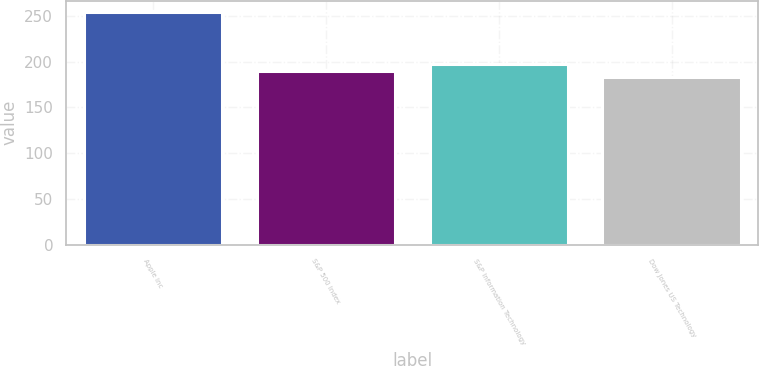<chart> <loc_0><loc_0><loc_500><loc_500><bar_chart><fcel>Apple Inc<fcel>S&P 500 Index<fcel>S&P Information Technology<fcel>Dow Jones US Technology<nl><fcel>254<fcel>190.1<fcel>197.2<fcel>183<nl></chart> 